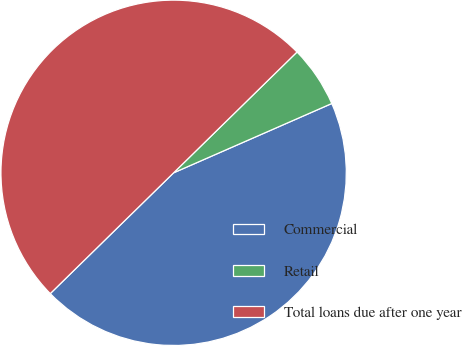Convert chart to OTSL. <chart><loc_0><loc_0><loc_500><loc_500><pie_chart><fcel>Commercial<fcel>Retail<fcel>Total loans due after one year<nl><fcel>44.24%<fcel>5.76%<fcel>50.0%<nl></chart> 